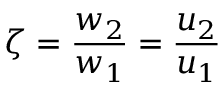<formula> <loc_0><loc_0><loc_500><loc_500>\zeta = \frac { w _ { 2 } } { w _ { 1 } } = \frac { u _ { 2 } } { u _ { 1 } }</formula> 